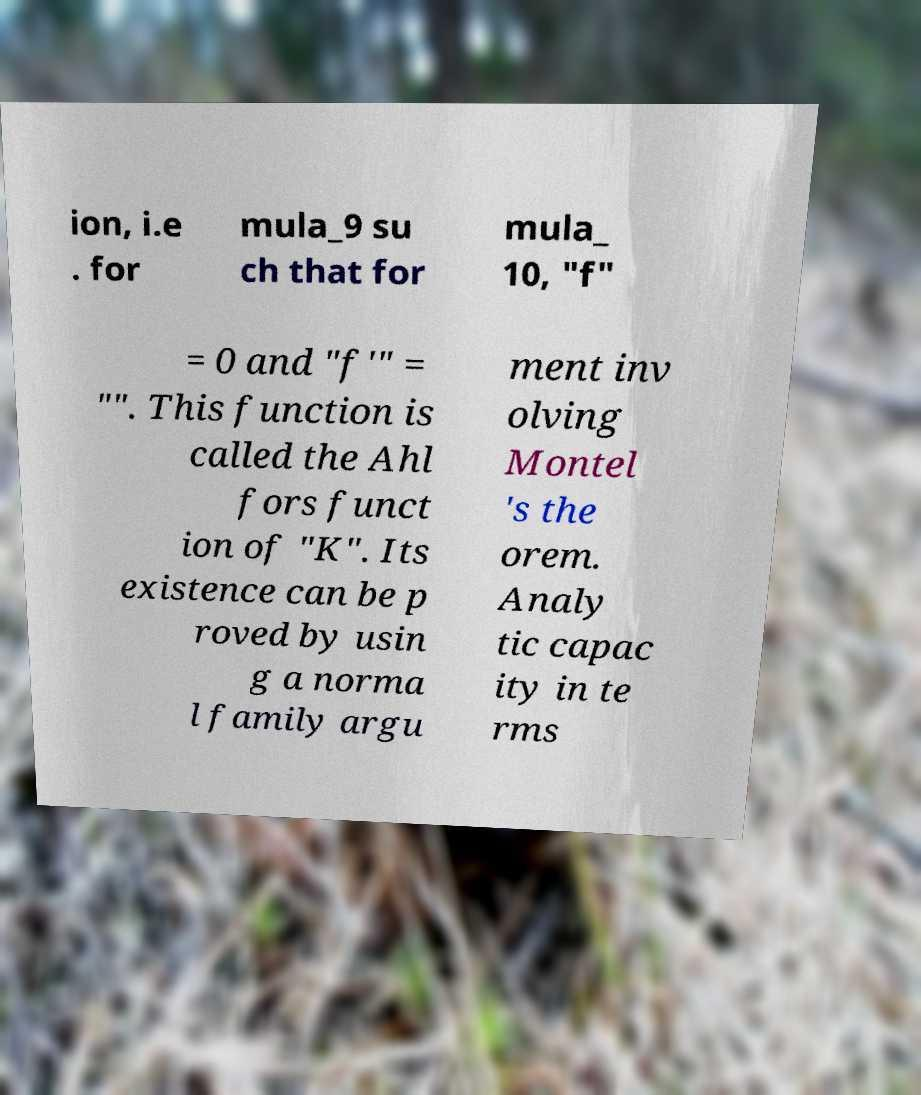Please identify and transcribe the text found in this image. ion, i.e . for mula_9 su ch that for mula_ 10, "f" = 0 and "f′" = "". This function is called the Ahl fors funct ion of "K". Its existence can be p roved by usin g a norma l family argu ment inv olving Montel 's the orem. Analy tic capac ity in te rms 